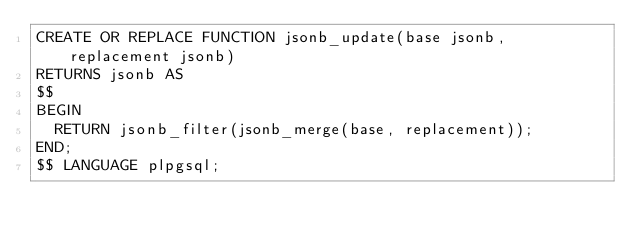Convert code to text. <code><loc_0><loc_0><loc_500><loc_500><_SQL_>CREATE OR REPLACE FUNCTION jsonb_update(base jsonb, replacement jsonb) 
RETURNS jsonb AS
$$
BEGIN
  RETURN jsonb_filter(jsonb_merge(base, replacement));
END;
$$ LANGUAGE plpgsql;
</code> 